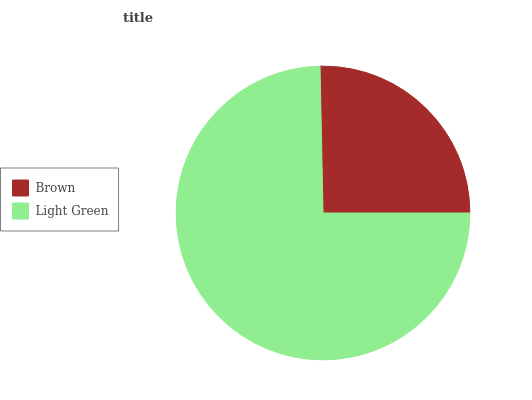Is Brown the minimum?
Answer yes or no. Yes. Is Light Green the maximum?
Answer yes or no. Yes. Is Light Green the minimum?
Answer yes or no. No. Is Light Green greater than Brown?
Answer yes or no. Yes. Is Brown less than Light Green?
Answer yes or no. Yes. Is Brown greater than Light Green?
Answer yes or no. No. Is Light Green less than Brown?
Answer yes or no. No. Is Light Green the high median?
Answer yes or no. Yes. Is Brown the low median?
Answer yes or no. Yes. Is Brown the high median?
Answer yes or no. No. Is Light Green the low median?
Answer yes or no. No. 